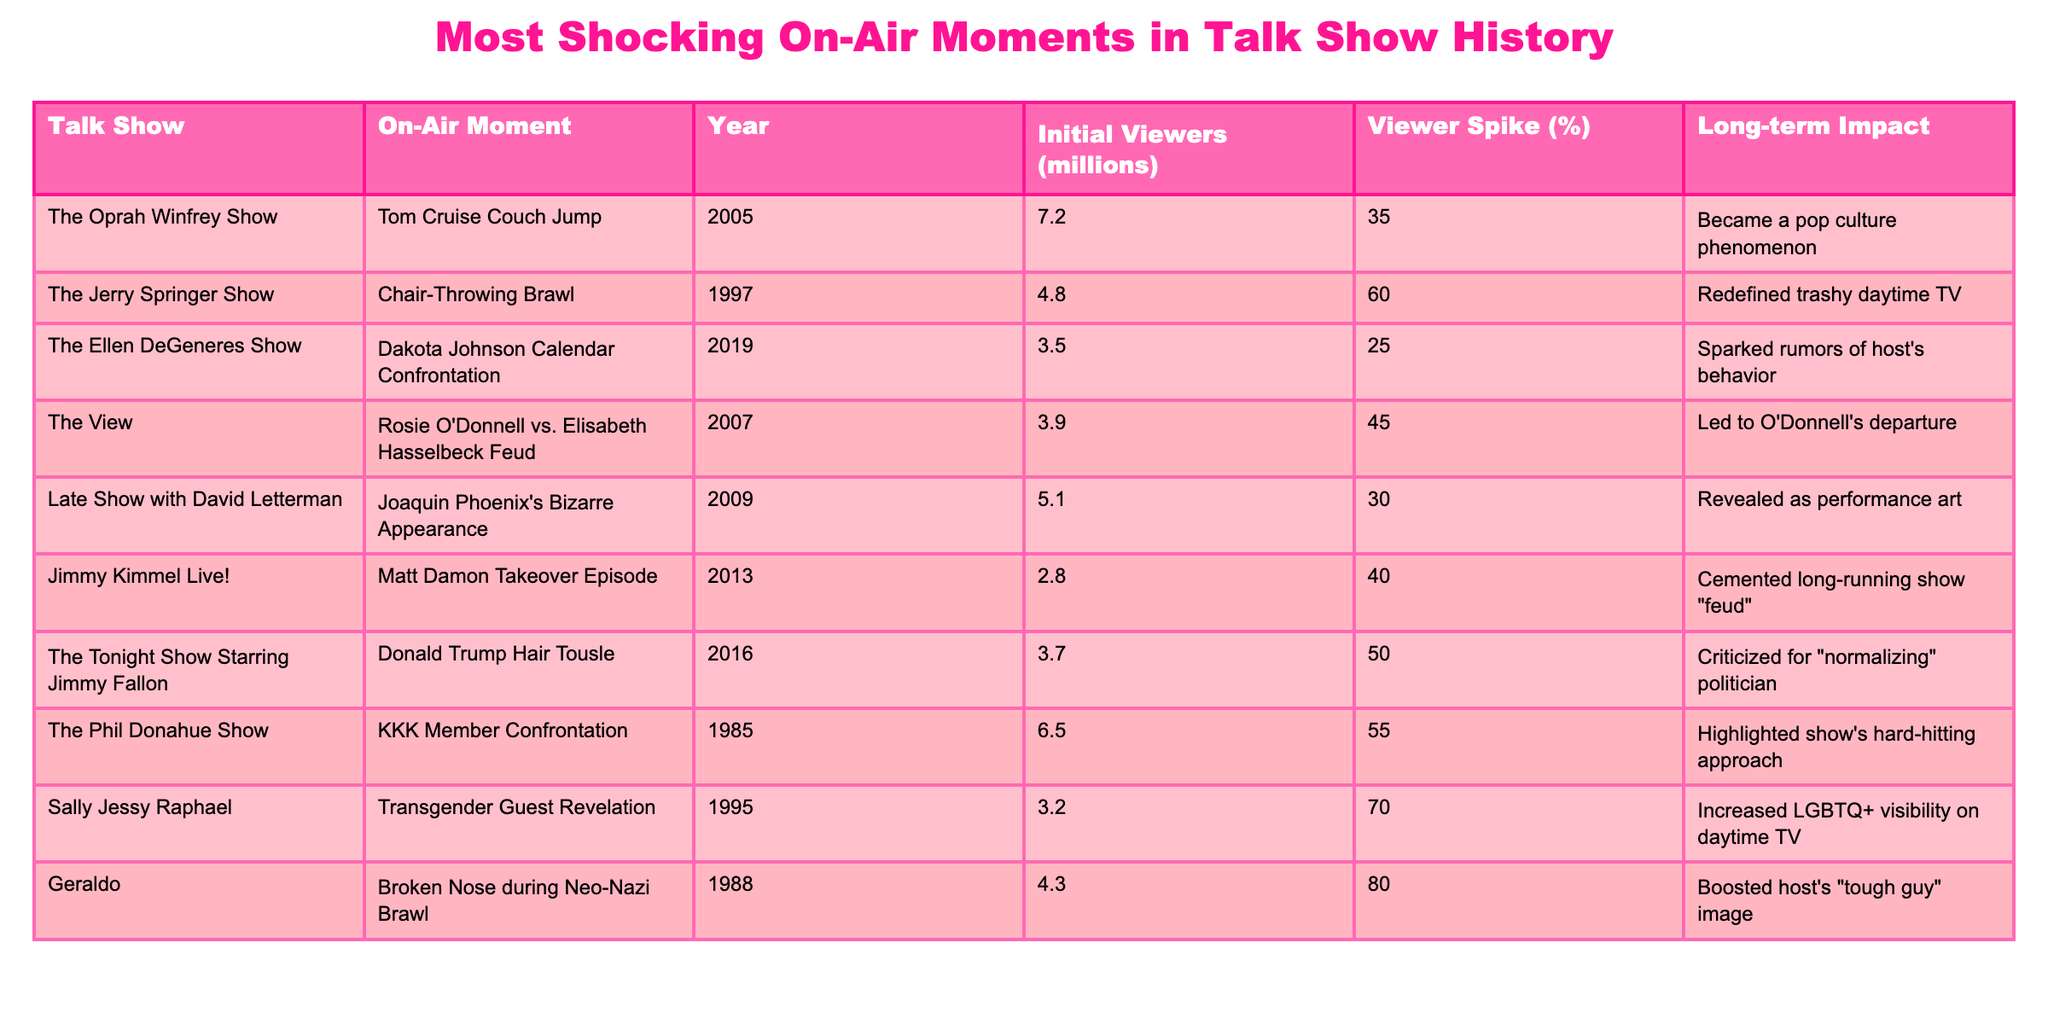What was the viewer spike percentage for the 'Broken Nose during Neo-Nazi Brawl' incident? The table indicates that the viewer spike percentage for the 'Broken Nose during Neo-Nazi Brawl' incident from the Geraldo show was listed as 80%.
Answer: 80% Which talk show featured the most shocking on-air moment in 1995? According to the table, the most shocking on-air moment in 1995 was the 'Transgender Guest Revelation' on the Sally Jessy Raphael show.
Answer: Sally Jessy Raphael What is the average initial viewership (in millions) for the talk shows listed? To find the average, first sum the initial viewership numbers: 7.2 + 4.8 + 3.5 + 3.9 + 5.1 + 2.8 + 3.7 + 6.5 + 3.2 + 4.3 = 43.0 million. There are 10 shows, so the average is 43.0/10 = 4.3 million.
Answer: 4.3 million Which incident had the longest long-term impact of increased visibility for a specific community? The table points to the 'Transgender Guest Revelation' on the Sally Jessy Raphael show as having a long-term impact that increased LGBTQ+ visibility on daytime TV.
Answer: Transgender Guest Revelation True or False: The 'Tom Cruise Couch Jump' incident had a viewer spike of 40%. The table shows that the viewer spike percentage for the 'Tom Cruise Couch Jump' incident was 35%, which means the statement is false.
Answer: False What is the difference in initial viewers between 'Donald Trump Hair Tousle' and 'Dakota Johnson Calendar Confrontation'? The 'Donald Trump Hair Tousle' had 3.7 million initial viewers, while 'Dakota Johnson Calendar Confrontation' had 3.5 million. The difference is 3.7 - 3.5 = 0.2 million or 200,000 viewers.
Answer: 0.2 million Which show had a better long-term impact: 'Chair-Throwing Brawl' or 'KKK Member Confrontation'? The table indicates that the 'Chair-Throwing Brawl' redefined trashy daytime TV, while the 'KKK Member Confrontation' highlighted the show's hard-hitting approach. Both had significant impacts, but the content and public perceptions suggest the KKK confrontation may resonate more due to its serious nature.
Answer: KKK Member Confrontation How many incidents had a viewer spike percentage over 50%? By examining the table, the incidents with a viewer spike over 50% are the 'Chair-Throwing Brawl' (60%), 'KKK Member Confrontation' (55%), and 'Broken Nose during Neo-Nazi Brawl' (80%). That totals 3 incidents.
Answer: 3 